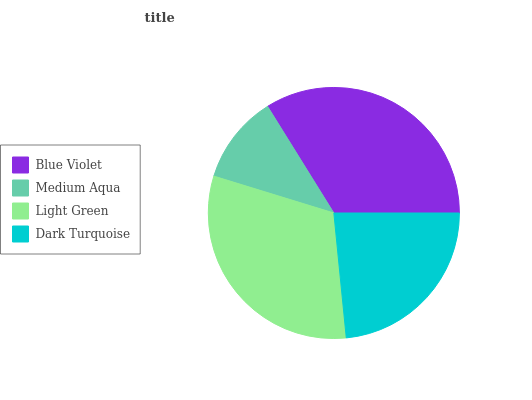Is Medium Aqua the minimum?
Answer yes or no. Yes. Is Blue Violet the maximum?
Answer yes or no. Yes. Is Light Green the minimum?
Answer yes or no. No. Is Light Green the maximum?
Answer yes or no. No. Is Light Green greater than Medium Aqua?
Answer yes or no. Yes. Is Medium Aqua less than Light Green?
Answer yes or no. Yes. Is Medium Aqua greater than Light Green?
Answer yes or no. No. Is Light Green less than Medium Aqua?
Answer yes or no. No. Is Light Green the high median?
Answer yes or no. Yes. Is Dark Turquoise the low median?
Answer yes or no. Yes. Is Blue Violet the high median?
Answer yes or no. No. Is Medium Aqua the low median?
Answer yes or no. No. 